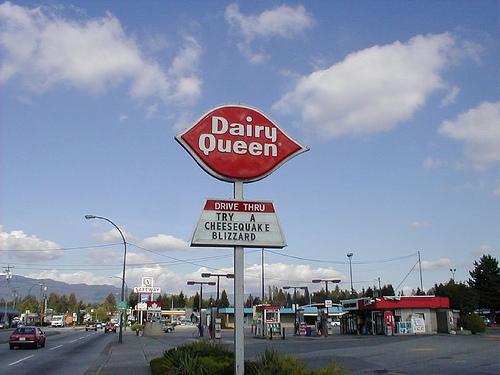What does the sign say?
Answer briefly. Dairy queen. What kind of animal is shown on the car wash sign?
Concise answer only. None. What does the sign indicate you should try?
Give a very brief answer. Cheesequake blizzard. Is this a Jewish store?
Be succinct. No. What is the red sign?
Concise answer only. Dairy queen. How many cars are in the picture?
Give a very brief answer. 3. What does this sign say?
Concise answer only. Dairy queen. Where was the photo taken?
Give a very brief answer. Dairy queen. How many street lights are there?
Answer briefly. 3. What does the giant sign say?
Be succinct. Dairy queen. What does the red sign say to do?
Give a very brief answer. Try cheesequake blizzard. What fast food company is in the photo?
Be succinct. Dairy queen. Does this place have a drive thru?
Short answer required. Yes. What kind of sign is this?
Be succinct. Dairy queen. Is this a beach?
Write a very short answer. No. What is the last letter on the sign in this scene?
Keep it brief. D. Would you get a ticket if you disobeyed this sign?
Keep it brief. No. Is this an industrial area?
Concise answer only. No. How many letters are in the word on the sign?
Write a very short answer. 10. What brand of restaurant is depicted?
Short answer required. Dairy queen. What is the name of the cafe?
Keep it brief. Dairy queen. 